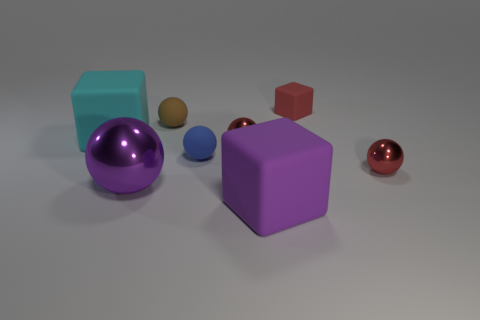Subtract 1 balls. How many balls are left? 4 Subtract all brown spheres. How many spheres are left? 4 Subtract all big spheres. How many spheres are left? 4 Subtract all purple balls. Subtract all purple cylinders. How many balls are left? 4 Add 2 small brown balls. How many objects exist? 10 Subtract all balls. How many objects are left? 3 Add 3 tiny brown balls. How many tiny brown balls exist? 4 Subtract 1 brown balls. How many objects are left? 7 Subtract all large yellow metal cubes. Subtract all big rubber blocks. How many objects are left? 6 Add 7 big purple cubes. How many big purple cubes are left? 8 